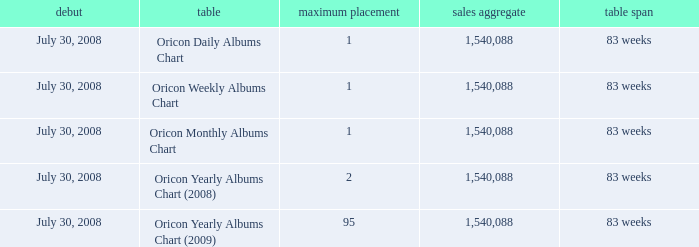Which Sales Total has a Chart of oricon monthly albums chart? 1540088.0. 